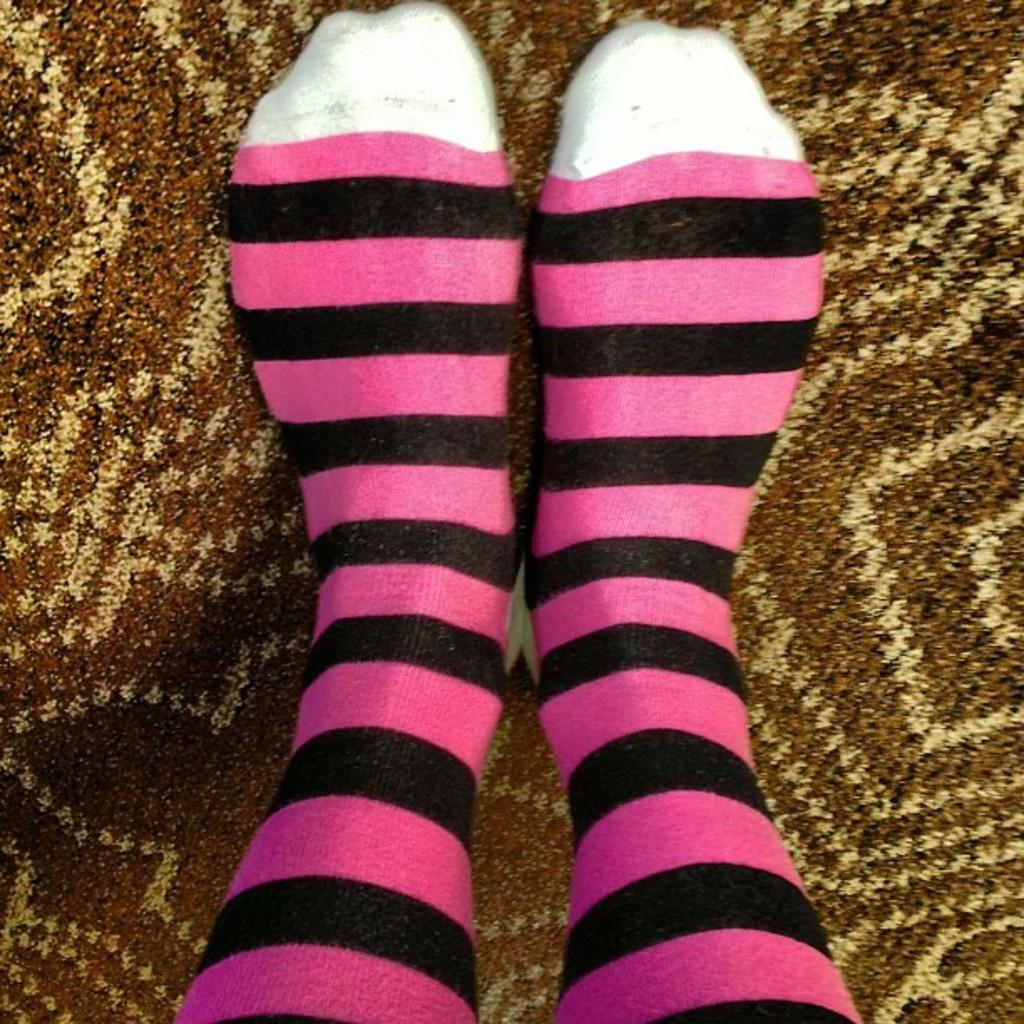What part of a person can be seen in the image? There are legs of a person visible in the image. What type of vacation is the person planning based on the image? There is no information about a vacation or any plans in the image; it only shows the legs of a person. 